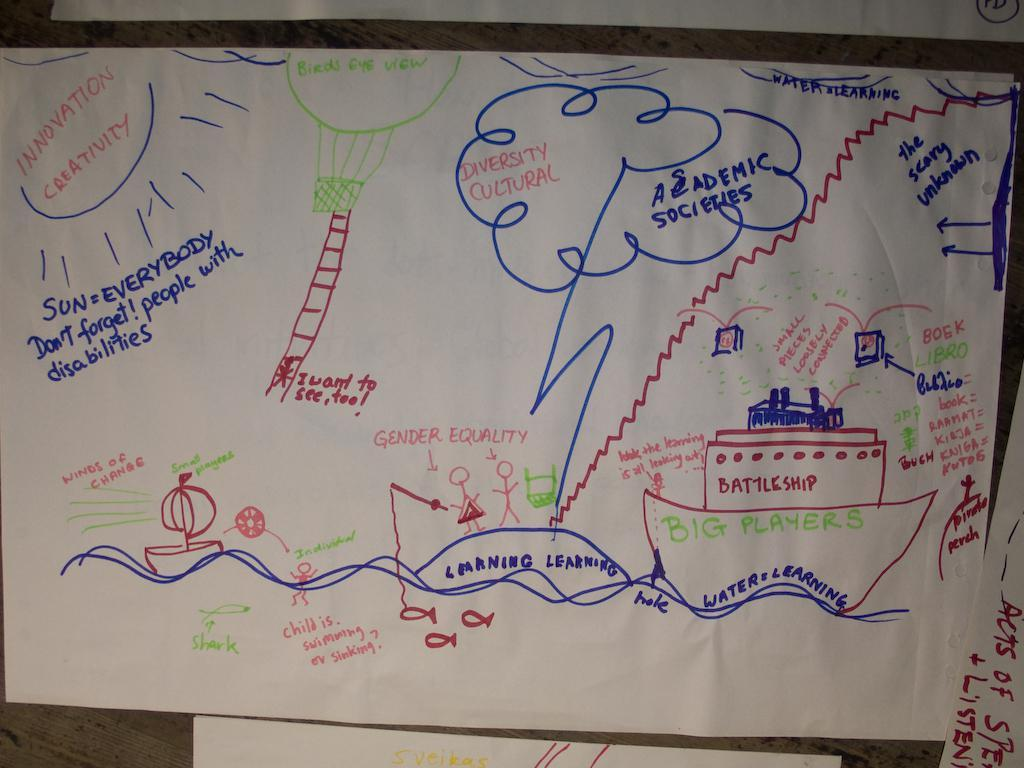What is attached to the wall in the image? There are white color papers attached to a wall. What can be seen on the papers? There is text on the papers. What is the main subject in the middle of the image? There is a drawing of pictures in the middle of the image. Can you see a friend playing with a cub in the quicksand in the image? There is no friend, cub, or quicksand present in the image. The image features white color papers with text attached to a wall and a drawing of pictures in the middle. 